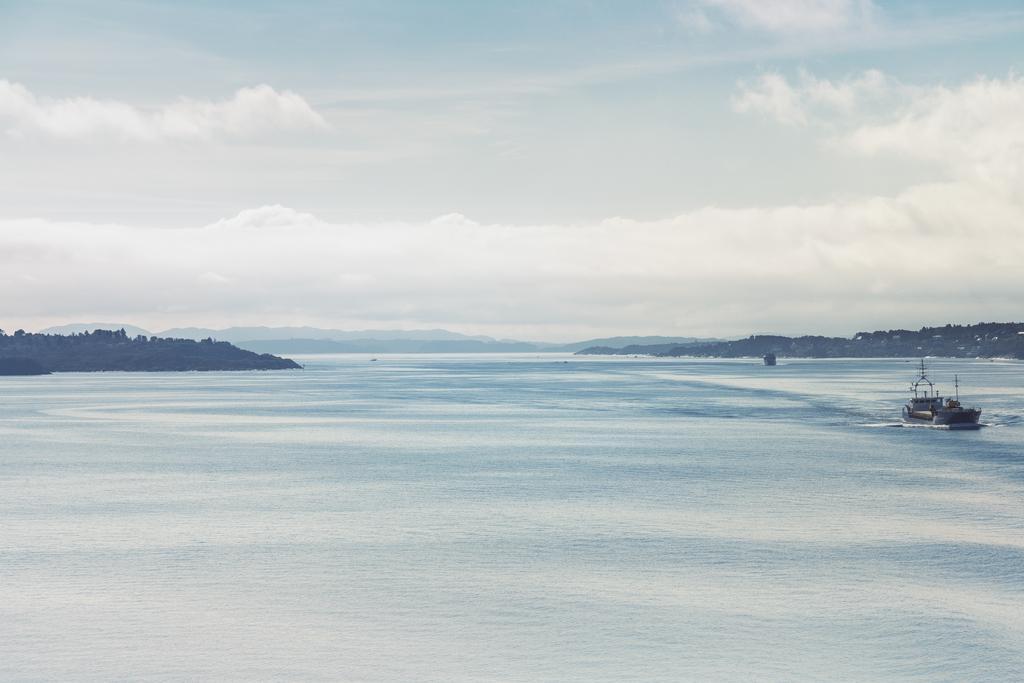In one or two sentences, can you explain what this image depicts? On the right side of the image, we can see a boat is sailing on the water. Background there are few mountains and sky. 